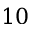<formula> <loc_0><loc_0><loc_500><loc_500>1 0</formula> 